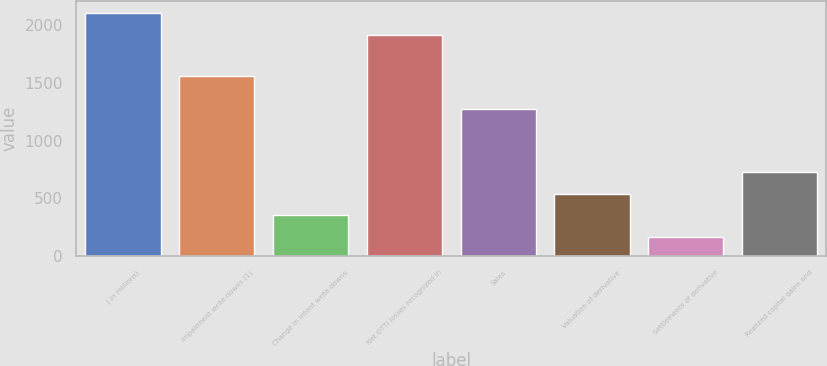Convert chart to OTSL. <chart><loc_0><loc_0><loc_500><loc_500><bar_chart><fcel>( in millions)<fcel>Impairment write-downs (1)<fcel>Change in intent write-downs<fcel>Net OTTI losses recognized in<fcel>Sales<fcel>Valuation of derivative<fcel>Settlements of derivative<fcel>Realized capital gains and<nl><fcel>2103.7<fcel>1562<fcel>357<fcel>1919<fcel>1272<fcel>541.7<fcel>162<fcel>726.4<nl></chart> 